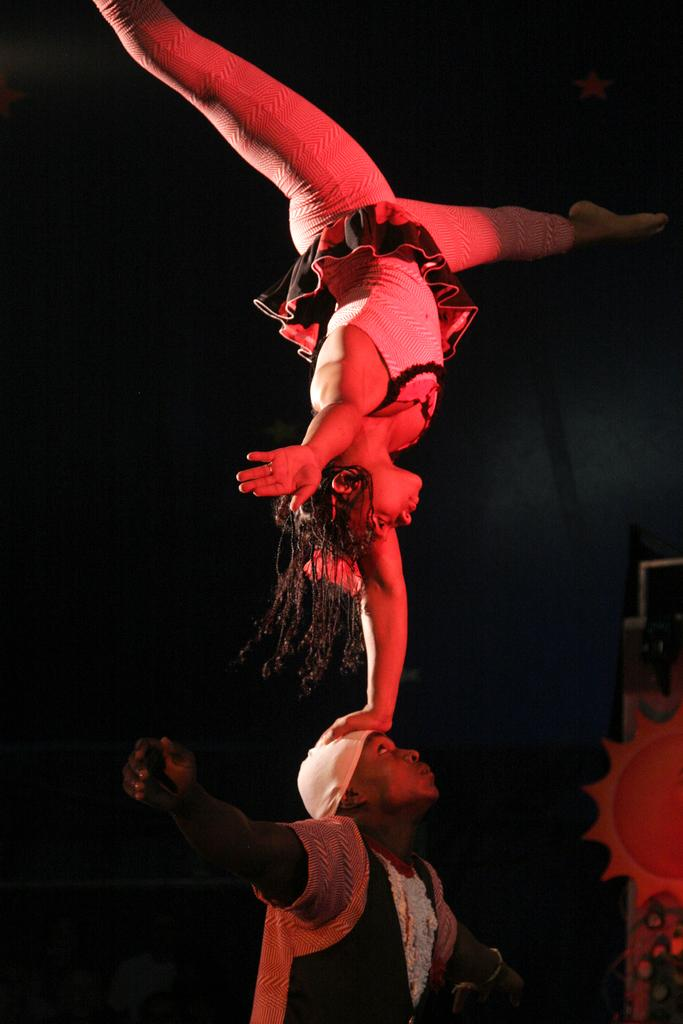How many people are in the image? There are two persons in the image. What are the actions of the two persons? One person is dancing, and the other person is standing. What is the color of the background in the image? The background of the image is black. How many passengers are visible on the train in the image? There is no train present in the image, so it is not possible to determine the number of passengers. What color are the eyes of the person in the image? The image does not show the person's eyes, so it is not possible to determine their color. 